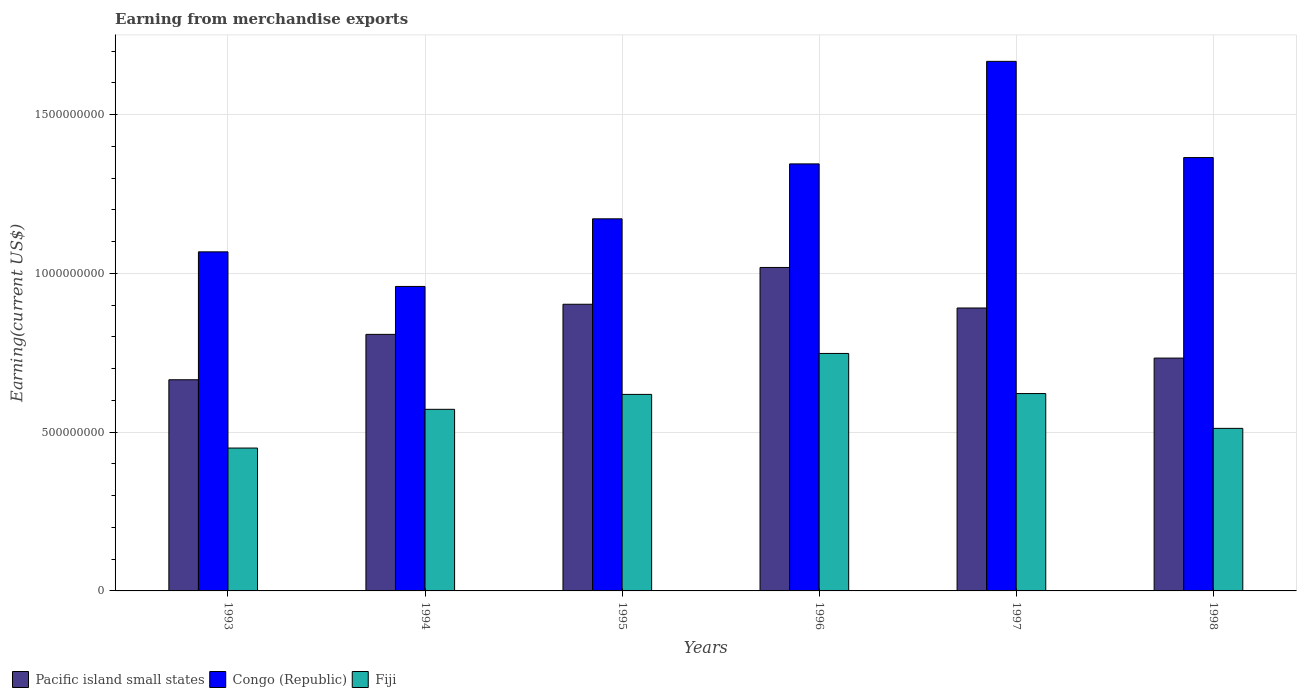Are the number of bars on each tick of the X-axis equal?
Provide a short and direct response. Yes. How many bars are there on the 3rd tick from the left?
Your answer should be compact. 3. How many bars are there on the 1st tick from the right?
Your response must be concise. 3. In how many cases, is the number of bars for a given year not equal to the number of legend labels?
Your response must be concise. 0. What is the amount earned from merchandise exports in Pacific island small states in 1997?
Offer a terse response. 8.91e+08. Across all years, what is the maximum amount earned from merchandise exports in Congo (Republic)?
Offer a terse response. 1.67e+09. Across all years, what is the minimum amount earned from merchandise exports in Pacific island small states?
Provide a short and direct response. 6.65e+08. In which year was the amount earned from merchandise exports in Congo (Republic) minimum?
Offer a very short reply. 1994. What is the total amount earned from merchandise exports in Fiji in the graph?
Make the answer very short. 3.52e+09. What is the difference between the amount earned from merchandise exports in Fiji in 1993 and that in 1998?
Make the answer very short. -6.20e+07. What is the difference between the amount earned from merchandise exports in Pacific island small states in 1993 and the amount earned from merchandise exports in Congo (Republic) in 1998?
Offer a very short reply. -7.00e+08. What is the average amount earned from merchandise exports in Congo (Republic) per year?
Ensure brevity in your answer.  1.26e+09. In the year 1993, what is the difference between the amount earned from merchandise exports in Congo (Republic) and amount earned from merchandise exports in Pacific island small states?
Your response must be concise. 4.03e+08. In how many years, is the amount earned from merchandise exports in Fiji greater than 700000000 US$?
Your response must be concise. 1. What is the ratio of the amount earned from merchandise exports in Pacific island small states in 1996 to that in 1998?
Offer a terse response. 1.39. Is the difference between the amount earned from merchandise exports in Congo (Republic) in 1996 and 1998 greater than the difference between the amount earned from merchandise exports in Pacific island small states in 1996 and 1998?
Ensure brevity in your answer.  No. What is the difference between the highest and the second highest amount earned from merchandise exports in Congo (Republic)?
Make the answer very short. 3.03e+08. What is the difference between the highest and the lowest amount earned from merchandise exports in Fiji?
Keep it short and to the point. 2.98e+08. What does the 3rd bar from the left in 1993 represents?
Your answer should be very brief. Fiji. What does the 2nd bar from the right in 1995 represents?
Offer a very short reply. Congo (Republic). How many bars are there?
Your answer should be very brief. 18. Are all the bars in the graph horizontal?
Ensure brevity in your answer.  No. What is the difference between two consecutive major ticks on the Y-axis?
Make the answer very short. 5.00e+08. Are the values on the major ticks of Y-axis written in scientific E-notation?
Give a very brief answer. No. Does the graph contain any zero values?
Your response must be concise. No. Does the graph contain grids?
Provide a short and direct response. Yes. How many legend labels are there?
Provide a succinct answer. 3. How are the legend labels stacked?
Your answer should be very brief. Horizontal. What is the title of the graph?
Your response must be concise. Earning from merchandise exports. Does "Norway" appear as one of the legend labels in the graph?
Ensure brevity in your answer.  No. What is the label or title of the Y-axis?
Your answer should be compact. Earning(current US$). What is the Earning(current US$) of Pacific island small states in 1993?
Ensure brevity in your answer.  6.65e+08. What is the Earning(current US$) of Congo (Republic) in 1993?
Make the answer very short. 1.07e+09. What is the Earning(current US$) of Fiji in 1993?
Keep it short and to the point. 4.50e+08. What is the Earning(current US$) in Pacific island small states in 1994?
Provide a short and direct response. 8.08e+08. What is the Earning(current US$) in Congo (Republic) in 1994?
Make the answer very short. 9.59e+08. What is the Earning(current US$) in Fiji in 1994?
Keep it short and to the point. 5.72e+08. What is the Earning(current US$) in Pacific island small states in 1995?
Give a very brief answer. 9.03e+08. What is the Earning(current US$) in Congo (Republic) in 1995?
Offer a terse response. 1.17e+09. What is the Earning(current US$) in Fiji in 1995?
Your response must be concise. 6.19e+08. What is the Earning(current US$) in Pacific island small states in 1996?
Your answer should be very brief. 1.02e+09. What is the Earning(current US$) in Congo (Republic) in 1996?
Provide a succinct answer. 1.34e+09. What is the Earning(current US$) in Fiji in 1996?
Give a very brief answer. 7.48e+08. What is the Earning(current US$) of Pacific island small states in 1997?
Your answer should be very brief. 8.91e+08. What is the Earning(current US$) of Congo (Republic) in 1997?
Provide a short and direct response. 1.67e+09. What is the Earning(current US$) of Fiji in 1997?
Offer a terse response. 6.22e+08. What is the Earning(current US$) in Pacific island small states in 1998?
Keep it short and to the point. 7.33e+08. What is the Earning(current US$) in Congo (Republic) in 1998?
Your response must be concise. 1.36e+09. What is the Earning(current US$) in Fiji in 1998?
Offer a terse response. 5.12e+08. Across all years, what is the maximum Earning(current US$) of Pacific island small states?
Your response must be concise. 1.02e+09. Across all years, what is the maximum Earning(current US$) of Congo (Republic)?
Your answer should be compact. 1.67e+09. Across all years, what is the maximum Earning(current US$) in Fiji?
Offer a very short reply. 7.48e+08. Across all years, what is the minimum Earning(current US$) of Pacific island small states?
Your response must be concise. 6.65e+08. Across all years, what is the minimum Earning(current US$) in Congo (Republic)?
Your response must be concise. 9.59e+08. Across all years, what is the minimum Earning(current US$) of Fiji?
Keep it short and to the point. 4.50e+08. What is the total Earning(current US$) in Pacific island small states in the graph?
Offer a very short reply. 5.02e+09. What is the total Earning(current US$) in Congo (Republic) in the graph?
Provide a short and direct response. 7.58e+09. What is the total Earning(current US$) in Fiji in the graph?
Keep it short and to the point. 3.52e+09. What is the difference between the Earning(current US$) of Pacific island small states in 1993 and that in 1994?
Provide a short and direct response. -1.43e+08. What is the difference between the Earning(current US$) of Congo (Republic) in 1993 and that in 1994?
Your response must be concise. 1.09e+08. What is the difference between the Earning(current US$) of Fiji in 1993 and that in 1994?
Give a very brief answer. -1.22e+08. What is the difference between the Earning(current US$) in Pacific island small states in 1993 and that in 1995?
Make the answer very short. -2.38e+08. What is the difference between the Earning(current US$) of Congo (Republic) in 1993 and that in 1995?
Your response must be concise. -1.04e+08. What is the difference between the Earning(current US$) of Fiji in 1993 and that in 1995?
Your response must be concise. -1.69e+08. What is the difference between the Earning(current US$) of Pacific island small states in 1993 and that in 1996?
Keep it short and to the point. -3.54e+08. What is the difference between the Earning(current US$) of Congo (Republic) in 1993 and that in 1996?
Keep it short and to the point. -2.77e+08. What is the difference between the Earning(current US$) of Fiji in 1993 and that in 1996?
Keep it short and to the point. -2.98e+08. What is the difference between the Earning(current US$) in Pacific island small states in 1993 and that in 1997?
Offer a terse response. -2.26e+08. What is the difference between the Earning(current US$) of Congo (Republic) in 1993 and that in 1997?
Offer a very short reply. -6.00e+08. What is the difference between the Earning(current US$) in Fiji in 1993 and that in 1997?
Give a very brief answer. -1.72e+08. What is the difference between the Earning(current US$) in Pacific island small states in 1993 and that in 1998?
Provide a short and direct response. -6.83e+07. What is the difference between the Earning(current US$) of Congo (Republic) in 1993 and that in 1998?
Ensure brevity in your answer.  -2.97e+08. What is the difference between the Earning(current US$) in Fiji in 1993 and that in 1998?
Your response must be concise. -6.20e+07. What is the difference between the Earning(current US$) in Pacific island small states in 1994 and that in 1995?
Provide a succinct answer. -9.48e+07. What is the difference between the Earning(current US$) of Congo (Republic) in 1994 and that in 1995?
Give a very brief answer. -2.13e+08. What is the difference between the Earning(current US$) of Fiji in 1994 and that in 1995?
Your response must be concise. -4.70e+07. What is the difference between the Earning(current US$) in Pacific island small states in 1994 and that in 1996?
Provide a succinct answer. -2.11e+08. What is the difference between the Earning(current US$) in Congo (Republic) in 1994 and that in 1996?
Make the answer very short. -3.86e+08. What is the difference between the Earning(current US$) of Fiji in 1994 and that in 1996?
Your answer should be very brief. -1.76e+08. What is the difference between the Earning(current US$) of Pacific island small states in 1994 and that in 1997?
Offer a very short reply. -8.31e+07. What is the difference between the Earning(current US$) of Congo (Republic) in 1994 and that in 1997?
Your answer should be compact. -7.09e+08. What is the difference between the Earning(current US$) of Fiji in 1994 and that in 1997?
Make the answer very short. -4.96e+07. What is the difference between the Earning(current US$) of Pacific island small states in 1994 and that in 1998?
Provide a short and direct response. 7.47e+07. What is the difference between the Earning(current US$) of Congo (Republic) in 1994 and that in 1998?
Offer a very short reply. -4.06e+08. What is the difference between the Earning(current US$) in Fiji in 1994 and that in 1998?
Offer a terse response. 6.00e+07. What is the difference between the Earning(current US$) of Pacific island small states in 1995 and that in 1996?
Keep it short and to the point. -1.16e+08. What is the difference between the Earning(current US$) of Congo (Republic) in 1995 and that in 1996?
Your answer should be very brief. -1.73e+08. What is the difference between the Earning(current US$) in Fiji in 1995 and that in 1996?
Offer a very short reply. -1.29e+08. What is the difference between the Earning(current US$) in Pacific island small states in 1995 and that in 1997?
Your response must be concise. 1.18e+07. What is the difference between the Earning(current US$) in Congo (Republic) in 1995 and that in 1997?
Ensure brevity in your answer.  -4.96e+08. What is the difference between the Earning(current US$) in Fiji in 1995 and that in 1997?
Offer a terse response. -2.65e+06. What is the difference between the Earning(current US$) in Pacific island small states in 1995 and that in 1998?
Offer a very short reply. 1.70e+08. What is the difference between the Earning(current US$) of Congo (Republic) in 1995 and that in 1998?
Your response must be concise. -1.93e+08. What is the difference between the Earning(current US$) of Fiji in 1995 and that in 1998?
Your answer should be very brief. 1.07e+08. What is the difference between the Earning(current US$) of Pacific island small states in 1996 and that in 1997?
Offer a terse response. 1.28e+08. What is the difference between the Earning(current US$) of Congo (Republic) in 1996 and that in 1997?
Ensure brevity in your answer.  -3.23e+08. What is the difference between the Earning(current US$) of Fiji in 1996 and that in 1997?
Ensure brevity in your answer.  1.26e+08. What is the difference between the Earning(current US$) of Pacific island small states in 1996 and that in 1998?
Offer a very short reply. 2.85e+08. What is the difference between the Earning(current US$) in Congo (Republic) in 1996 and that in 1998?
Offer a terse response. -2.00e+07. What is the difference between the Earning(current US$) in Fiji in 1996 and that in 1998?
Provide a short and direct response. 2.36e+08. What is the difference between the Earning(current US$) in Pacific island small states in 1997 and that in 1998?
Your answer should be very brief. 1.58e+08. What is the difference between the Earning(current US$) in Congo (Republic) in 1997 and that in 1998?
Your response must be concise. 3.03e+08. What is the difference between the Earning(current US$) of Fiji in 1997 and that in 1998?
Offer a terse response. 1.10e+08. What is the difference between the Earning(current US$) in Pacific island small states in 1993 and the Earning(current US$) in Congo (Republic) in 1994?
Ensure brevity in your answer.  -2.94e+08. What is the difference between the Earning(current US$) of Pacific island small states in 1993 and the Earning(current US$) of Fiji in 1994?
Provide a short and direct response. 9.31e+07. What is the difference between the Earning(current US$) of Congo (Republic) in 1993 and the Earning(current US$) of Fiji in 1994?
Make the answer very short. 4.96e+08. What is the difference between the Earning(current US$) in Pacific island small states in 1993 and the Earning(current US$) in Congo (Republic) in 1995?
Your answer should be very brief. -5.07e+08. What is the difference between the Earning(current US$) in Pacific island small states in 1993 and the Earning(current US$) in Fiji in 1995?
Your answer should be compact. 4.61e+07. What is the difference between the Earning(current US$) in Congo (Republic) in 1993 and the Earning(current US$) in Fiji in 1995?
Provide a succinct answer. 4.49e+08. What is the difference between the Earning(current US$) of Pacific island small states in 1993 and the Earning(current US$) of Congo (Republic) in 1996?
Provide a short and direct response. -6.80e+08. What is the difference between the Earning(current US$) of Pacific island small states in 1993 and the Earning(current US$) of Fiji in 1996?
Your answer should be compact. -8.29e+07. What is the difference between the Earning(current US$) in Congo (Republic) in 1993 and the Earning(current US$) in Fiji in 1996?
Give a very brief answer. 3.20e+08. What is the difference between the Earning(current US$) of Pacific island small states in 1993 and the Earning(current US$) of Congo (Republic) in 1997?
Offer a terse response. -1.00e+09. What is the difference between the Earning(current US$) in Pacific island small states in 1993 and the Earning(current US$) in Fiji in 1997?
Your response must be concise. 4.35e+07. What is the difference between the Earning(current US$) of Congo (Republic) in 1993 and the Earning(current US$) of Fiji in 1997?
Provide a succinct answer. 4.46e+08. What is the difference between the Earning(current US$) of Pacific island small states in 1993 and the Earning(current US$) of Congo (Republic) in 1998?
Ensure brevity in your answer.  -7.00e+08. What is the difference between the Earning(current US$) of Pacific island small states in 1993 and the Earning(current US$) of Fiji in 1998?
Offer a very short reply. 1.53e+08. What is the difference between the Earning(current US$) of Congo (Republic) in 1993 and the Earning(current US$) of Fiji in 1998?
Offer a very short reply. 5.56e+08. What is the difference between the Earning(current US$) of Pacific island small states in 1994 and the Earning(current US$) of Congo (Republic) in 1995?
Your response must be concise. -3.64e+08. What is the difference between the Earning(current US$) in Pacific island small states in 1994 and the Earning(current US$) in Fiji in 1995?
Your response must be concise. 1.89e+08. What is the difference between the Earning(current US$) of Congo (Republic) in 1994 and the Earning(current US$) of Fiji in 1995?
Offer a terse response. 3.40e+08. What is the difference between the Earning(current US$) in Pacific island small states in 1994 and the Earning(current US$) in Congo (Republic) in 1996?
Make the answer very short. -5.37e+08. What is the difference between the Earning(current US$) of Pacific island small states in 1994 and the Earning(current US$) of Fiji in 1996?
Keep it short and to the point. 6.01e+07. What is the difference between the Earning(current US$) of Congo (Republic) in 1994 and the Earning(current US$) of Fiji in 1996?
Ensure brevity in your answer.  2.11e+08. What is the difference between the Earning(current US$) of Pacific island small states in 1994 and the Earning(current US$) of Congo (Republic) in 1997?
Give a very brief answer. -8.60e+08. What is the difference between the Earning(current US$) in Pacific island small states in 1994 and the Earning(current US$) in Fiji in 1997?
Ensure brevity in your answer.  1.86e+08. What is the difference between the Earning(current US$) in Congo (Republic) in 1994 and the Earning(current US$) in Fiji in 1997?
Your answer should be compact. 3.37e+08. What is the difference between the Earning(current US$) in Pacific island small states in 1994 and the Earning(current US$) in Congo (Republic) in 1998?
Make the answer very short. -5.57e+08. What is the difference between the Earning(current US$) of Pacific island small states in 1994 and the Earning(current US$) of Fiji in 1998?
Offer a very short reply. 2.96e+08. What is the difference between the Earning(current US$) of Congo (Republic) in 1994 and the Earning(current US$) of Fiji in 1998?
Your answer should be very brief. 4.47e+08. What is the difference between the Earning(current US$) of Pacific island small states in 1995 and the Earning(current US$) of Congo (Republic) in 1996?
Provide a short and direct response. -4.42e+08. What is the difference between the Earning(current US$) in Pacific island small states in 1995 and the Earning(current US$) in Fiji in 1996?
Make the answer very short. 1.55e+08. What is the difference between the Earning(current US$) in Congo (Republic) in 1995 and the Earning(current US$) in Fiji in 1996?
Your response must be concise. 4.24e+08. What is the difference between the Earning(current US$) of Pacific island small states in 1995 and the Earning(current US$) of Congo (Republic) in 1997?
Your response must be concise. -7.65e+08. What is the difference between the Earning(current US$) in Pacific island small states in 1995 and the Earning(current US$) in Fiji in 1997?
Offer a terse response. 2.81e+08. What is the difference between the Earning(current US$) in Congo (Republic) in 1995 and the Earning(current US$) in Fiji in 1997?
Provide a short and direct response. 5.50e+08. What is the difference between the Earning(current US$) of Pacific island small states in 1995 and the Earning(current US$) of Congo (Republic) in 1998?
Your answer should be very brief. -4.62e+08. What is the difference between the Earning(current US$) in Pacific island small states in 1995 and the Earning(current US$) in Fiji in 1998?
Your response must be concise. 3.91e+08. What is the difference between the Earning(current US$) in Congo (Republic) in 1995 and the Earning(current US$) in Fiji in 1998?
Provide a succinct answer. 6.60e+08. What is the difference between the Earning(current US$) of Pacific island small states in 1996 and the Earning(current US$) of Congo (Republic) in 1997?
Your answer should be very brief. -6.49e+08. What is the difference between the Earning(current US$) in Pacific island small states in 1996 and the Earning(current US$) in Fiji in 1997?
Ensure brevity in your answer.  3.97e+08. What is the difference between the Earning(current US$) in Congo (Republic) in 1996 and the Earning(current US$) in Fiji in 1997?
Provide a short and direct response. 7.23e+08. What is the difference between the Earning(current US$) in Pacific island small states in 1996 and the Earning(current US$) in Congo (Republic) in 1998?
Provide a succinct answer. -3.46e+08. What is the difference between the Earning(current US$) in Pacific island small states in 1996 and the Earning(current US$) in Fiji in 1998?
Provide a short and direct response. 5.07e+08. What is the difference between the Earning(current US$) of Congo (Republic) in 1996 and the Earning(current US$) of Fiji in 1998?
Provide a succinct answer. 8.33e+08. What is the difference between the Earning(current US$) of Pacific island small states in 1997 and the Earning(current US$) of Congo (Republic) in 1998?
Make the answer very short. -4.74e+08. What is the difference between the Earning(current US$) of Pacific island small states in 1997 and the Earning(current US$) of Fiji in 1998?
Offer a terse response. 3.79e+08. What is the difference between the Earning(current US$) of Congo (Republic) in 1997 and the Earning(current US$) of Fiji in 1998?
Give a very brief answer. 1.16e+09. What is the average Earning(current US$) in Pacific island small states per year?
Ensure brevity in your answer.  8.37e+08. What is the average Earning(current US$) of Congo (Republic) per year?
Make the answer very short. 1.26e+09. What is the average Earning(current US$) of Fiji per year?
Provide a short and direct response. 5.87e+08. In the year 1993, what is the difference between the Earning(current US$) of Pacific island small states and Earning(current US$) of Congo (Republic)?
Give a very brief answer. -4.03e+08. In the year 1993, what is the difference between the Earning(current US$) of Pacific island small states and Earning(current US$) of Fiji?
Your response must be concise. 2.15e+08. In the year 1993, what is the difference between the Earning(current US$) of Congo (Republic) and Earning(current US$) of Fiji?
Provide a short and direct response. 6.18e+08. In the year 1994, what is the difference between the Earning(current US$) in Pacific island small states and Earning(current US$) in Congo (Republic)?
Your answer should be very brief. -1.51e+08. In the year 1994, what is the difference between the Earning(current US$) in Pacific island small states and Earning(current US$) in Fiji?
Give a very brief answer. 2.36e+08. In the year 1994, what is the difference between the Earning(current US$) in Congo (Republic) and Earning(current US$) in Fiji?
Your response must be concise. 3.87e+08. In the year 1995, what is the difference between the Earning(current US$) of Pacific island small states and Earning(current US$) of Congo (Republic)?
Offer a terse response. -2.69e+08. In the year 1995, what is the difference between the Earning(current US$) in Pacific island small states and Earning(current US$) in Fiji?
Keep it short and to the point. 2.84e+08. In the year 1995, what is the difference between the Earning(current US$) in Congo (Republic) and Earning(current US$) in Fiji?
Give a very brief answer. 5.53e+08. In the year 1996, what is the difference between the Earning(current US$) in Pacific island small states and Earning(current US$) in Congo (Republic)?
Keep it short and to the point. -3.26e+08. In the year 1996, what is the difference between the Earning(current US$) of Pacific island small states and Earning(current US$) of Fiji?
Ensure brevity in your answer.  2.71e+08. In the year 1996, what is the difference between the Earning(current US$) in Congo (Republic) and Earning(current US$) in Fiji?
Offer a terse response. 5.97e+08. In the year 1997, what is the difference between the Earning(current US$) of Pacific island small states and Earning(current US$) of Congo (Republic)?
Your answer should be very brief. -7.77e+08. In the year 1997, what is the difference between the Earning(current US$) of Pacific island small states and Earning(current US$) of Fiji?
Provide a short and direct response. 2.69e+08. In the year 1997, what is the difference between the Earning(current US$) of Congo (Republic) and Earning(current US$) of Fiji?
Offer a very short reply. 1.05e+09. In the year 1998, what is the difference between the Earning(current US$) in Pacific island small states and Earning(current US$) in Congo (Republic)?
Keep it short and to the point. -6.32e+08. In the year 1998, what is the difference between the Earning(current US$) in Pacific island small states and Earning(current US$) in Fiji?
Your answer should be compact. 2.21e+08. In the year 1998, what is the difference between the Earning(current US$) of Congo (Republic) and Earning(current US$) of Fiji?
Make the answer very short. 8.53e+08. What is the ratio of the Earning(current US$) of Pacific island small states in 1993 to that in 1994?
Keep it short and to the point. 0.82. What is the ratio of the Earning(current US$) in Congo (Republic) in 1993 to that in 1994?
Your response must be concise. 1.11. What is the ratio of the Earning(current US$) of Fiji in 1993 to that in 1994?
Your answer should be compact. 0.79. What is the ratio of the Earning(current US$) of Pacific island small states in 1993 to that in 1995?
Provide a short and direct response. 0.74. What is the ratio of the Earning(current US$) of Congo (Republic) in 1993 to that in 1995?
Make the answer very short. 0.91. What is the ratio of the Earning(current US$) in Fiji in 1993 to that in 1995?
Ensure brevity in your answer.  0.73. What is the ratio of the Earning(current US$) of Pacific island small states in 1993 to that in 1996?
Your answer should be very brief. 0.65. What is the ratio of the Earning(current US$) in Congo (Republic) in 1993 to that in 1996?
Your response must be concise. 0.79. What is the ratio of the Earning(current US$) in Fiji in 1993 to that in 1996?
Your answer should be compact. 0.6. What is the ratio of the Earning(current US$) of Pacific island small states in 1993 to that in 1997?
Make the answer very short. 0.75. What is the ratio of the Earning(current US$) of Congo (Republic) in 1993 to that in 1997?
Offer a terse response. 0.64. What is the ratio of the Earning(current US$) in Fiji in 1993 to that in 1997?
Offer a terse response. 0.72. What is the ratio of the Earning(current US$) of Pacific island small states in 1993 to that in 1998?
Give a very brief answer. 0.91. What is the ratio of the Earning(current US$) of Congo (Republic) in 1993 to that in 1998?
Keep it short and to the point. 0.78. What is the ratio of the Earning(current US$) of Fiji in 1993 to that in 1998?
Give a very brief answer. 0.88. What is the ratio of the Earning(current US$) of Pacific island small states in 1994 to that in 1995?
Make the answer very short. 0.9. What is the ratio of the Earning(current US$) of Congo (Republic) in 1994 to that in 1995?
Provide a succinct answer. 0.82. What is the ratio of the Earning(current US$) of Fiji in 1994 to that in 1995?
Keep it short and to the point. 0.92. What is the ratio of the Earning(current US$) in Pacific island small states in 1994 to that in 1996?
Provide a succinct answer. 0.79. What is the ratio of the Earning(current US$) of Congo (Republic) in 1994 to that in 1996?
Provide a succinct answer. 0.71. What is the ratio of the Earning(current US$) in Fiji in 1994 to that in 1996?
Your answer should be very brief. 0.76. What is the ratio of the Earning(current US$) in Pacific island small states in 1994 to that in 1997?
Your answer should be compact. 0.91. What is the ratio of the Earning(current US$) of Congo (Republic) in 1994 to that in 1997?
Give a very brief answer. 0.57. What is the ratio of the Earning(current US$) in Fiji in 1994 to that in 1997?
Offer a very short reply. 0.92. What is the ratio of the Earning(current US$) in Pacific island small states in 1994 to that in 1998?
Your answer should be very brief. 1.1. What is the ratio of the Earning(current US$) in Congo (Republic) in 1994 to that in 1998?
Provide a short and direct response. 0.7. What is the ratio of the Earning(current US$) of Fiji in 1994 to that in 1998?
Offer a terse response. 1.12. What is the ratio of the Earning(current US$) of Pacific island small states in 1995 to that in 1996?
Your answer should be very brief. 0.89. What is the ratio of the Earning(current US$) of Congo (Republic) in 1995 to that in 1996?
Offer a terse response. 0.87. What is the ratio of the Earning(current US$) in Fiji in 1995 to that in 1996?
Offer a terse response. 0.83. What is the ratio of the Earning(current US$) in Pacific island small states in 1995 to that in 1997?
Your answer should be compact. 1.01. What is the ratio of the Earning(current US$) of Congo (Republic) in 1995 to that in 1997?
Provide a succinct answer. 0.7. What is the ratio of the Earning(current US$) in Pacific island small states in 1995 to that in 1998?
Your answer should be compact. 1.23. What is the ratio of the Earning(current US$) of Congo (Republic) in 1995 to that in 1998?
Offer a very short reply. 0.86. What is the ratio of the Earning(current US$) in Fiji in 1995 to that in 1998?
Offer a terse response. 1.21. What is the ratio of the Earning(current US$) in Pacific island small states in 1996 to that in 1997?
Your answer should be compact. 1.14. What is the ratio of the Earning(current US$) of Congo (Republic) in 1996 to that in 1997?
Provide a succinct answer. 0.81. What is the ratio of the Earning(current US$) in Fiji in 1996 to that in 1997?
Provide a succinct answer. 1.2. What is the ratio of the Earning(current US$) in Pacific island small states in 1996 to that in 1998?
Your answer should be compact. 1.39. What is the ratio of the Earning(current US$) of Fiji in 1996 to that in 1998?
Provide a succinct answer. 1.46. What is the ratio of the Earning(current US$) in Pacific island small states in 1997 to that in 1998?
Provide a succinct answer. 1.22. What is the ratio of the Earning(current US$) in Congo (Republic) in 1997 to that in 1998?
Ensure brevity in your answer.  1.22. What is the ratio of the Earning(current US$) in Fiji in 1997 to that in 1998?
Ensure brevity in your answer.  1.21. What is the difference between the highest and the second highest Earning(current US$) in Pacific island small states?
Make the answer very short. 1.16e+08. What is the difference between the highest and the second highest Earning(current US$) in Congo (Republic)?
Make the answer very short. 3.03e+08. What is the difference between the highest and the second highest Earning(current US$) in Fiji?
Keep it short and to the point. 1.26e+08. What is the difference between the highest and the lowest Earning(current US$) of Pacific island small states?
Offer a terse response. 3.54e+08. What is the difference between the highest and the lowest Earning(current US$) in Congo (Republic)?
Your answer should be compact. 7.09e+08. What is the difference between the highest and the lowest Earning(current US$) in Fiji?
Provide a short and direct response. 2.98e+08. 